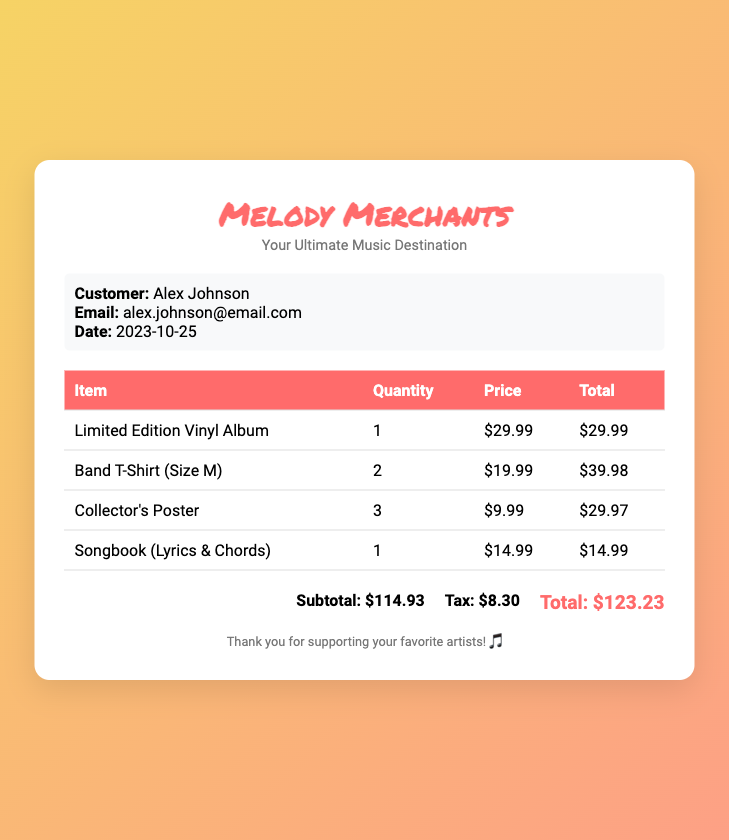What is the customer's name? The customer's name is listed at the top of the bill document.
Answer: Alex Johnson What is the email address of the customer? The email address can be found in the customer information section.
Answer: alex.johnson@email.com What is the date of the purchase? The date is mentioned in the customer information section of the document.
Answer: 2023-10-25 How many Limited Edition Vinyl Albums were purchased? The quantity of the item is specified in the table of items.
Answer: 1 What is the price of the Band T-Shirt? The price for the Band T-Shirt is stated in the table.
Answer: $19.99 What is the subtotal amount? The subtotal is summarized at the bottom of the bill before tax.
Answer: $114.93 How much tax was added to the purchase? The tax amount is listed right after the subtotal in the summary section.
Answer: $8.30 What is the total cost of the bill? The total cost is the final amount displayed in the summary section.
Answer: $123.23 What item has the highest total cost? The item with the highest total is indicated in the table by the total prices.
Answer: Band T-Shirt (Size M) 